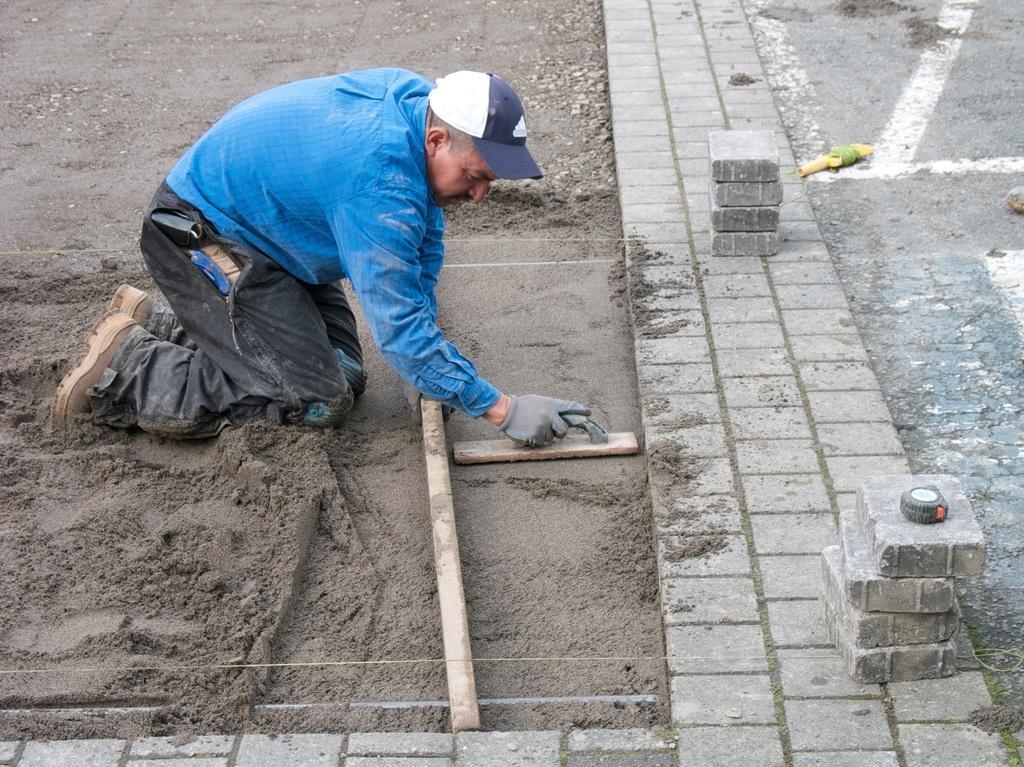Describe this image in one or two sentences. In this image we can see a person holding the object and doing the concrete. 